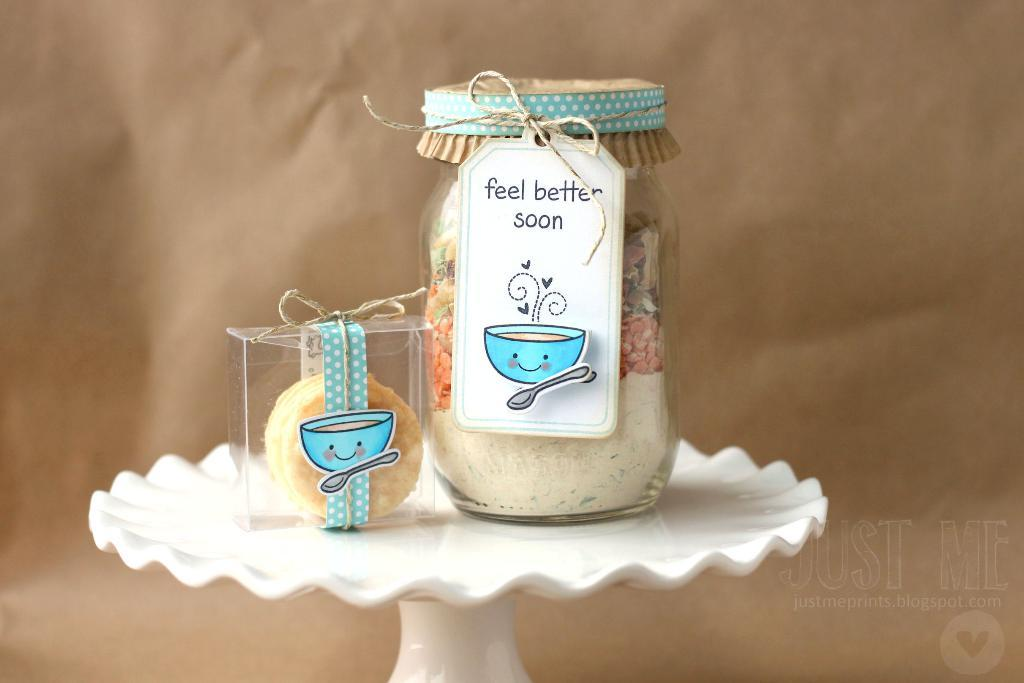<image>
Present a compact description of the photo's key features. A mason jar with ingredients with a label on the front that says feel better soon. 